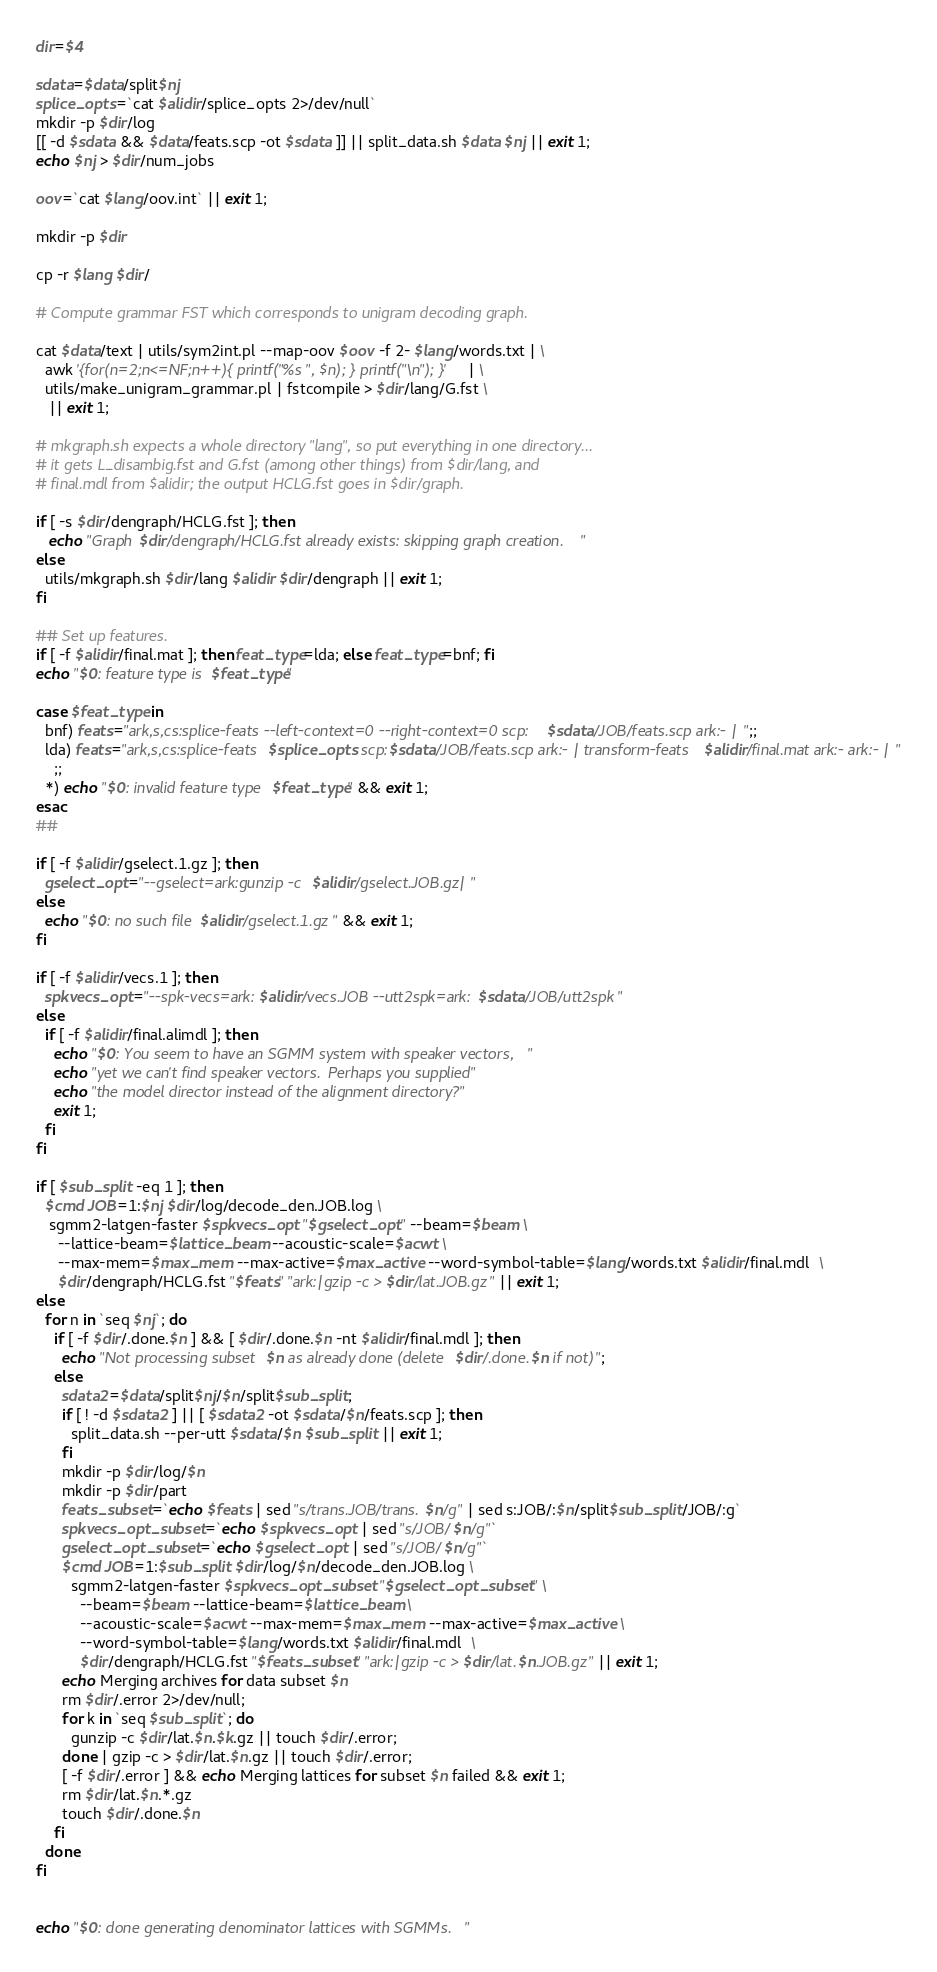<code> <loc_0><loc_0><loc_500><loc_500><_Bash_>dir=$4

sdata=$data/split$nj
splice_opts=`cat $alidir/splice_opts 2>/dev/null`
mkdir -p $dir/log
[[ -d $sdata && $data/feats.scp -ot $sdata ]] || split_data.sh $data $nj || exit 1;
echo $nj > $dir/num_jobs

oov=`cat $lang/oov.int` || exit 1;

mkdir -p $dir

cp -r $lang $dir/

# Compute grammar FST which corresponds to unigram decoding graph.

cat $data/text | utils/sym2int.pl --map-oov $oov -f 2- $lang/words.txt | \
  awk '{for(n=2;n<=NF;n++){ printf("%s ", $n); } printf("\n"); }' | \
  utils/make_unigram_grammar.pl | fstcompile > $dir/lang/G.fst \
   || exit 1;

# mkgraph.sh expects a whole directory "lang", so put everything in one directory...
# it gets L_disambig.fst and G.fst (among other things) from $dir/lang, and
# final.mdl from $alidir; the output HCLG.fst goes in $dir/graph.

if [ -s $dir/dengraph/HCLG.fst ]; then
   echo "Graph $dir/dengraph/HCLG.fst already exists: skipping graph creation."
else
  utils/mkgraph.sh $dir/lang $alidir $dir/dengraph || exit 1;
fi

## Set up features.
if [ -f $alidir/final.mat ]; then feat_type=lda; else feat_type=bnf; fi
echo "$0: feature type is $feat_type"

case $feat_type in
  bnf) feats="ark,s,cs:splice-feats --left-context=0 --right-context=0 scp:$sdata/JOB/feats.scp ark:- |";;
  lda) feats="ark,s,cs:splice-feats $splice_opts scp:$sdata/JOB/feats.scp ark:- | transform-feats $alidir/final.mat ark:- ark:- |"
    ;;
  *) echo "$0: invalid feature type $feat_type" && exit 1;
esac
##

if [ -f $alidir/gselect.1.gz ]; then
  gselect_opt="--gselect=ark:gunzip -c $alidir/gselect.JOB.gz|"
else
  echo "$0: no such file $alidir/gselect.1.gz" && exit 1;
fi

if [ -f $alidir/vecs.1 ]; then
  spkvecs_opt="--spk-vecs=ark:$alidir/vecs.JOB --utt2spk=ark:$sdata/JOB/utt2spk"
else
  if [ -f $alidir/final.alimdl ]; then
    echo "$0: You seem to have an SGMM system with speaker vectors,"
    echo "yet we can't find speaker vectors.  Perhaps you supplied"
    echo "the model director instead of the alignment directory?"
    exit 1;
  fi
fi

if [ $sub_split -eq 1 ]; then 
  $cmd JOB=1:$nj $dir/log/decode_den.JOB.log \
   sgmm2-latgen-faster $spkvecs_opt "$gselect_opt" --beam=$beam \
     --lattice-beam=$lattice_beam --acoustic-scale=$acwt \
     --max-mem=$max_mem --max-active=$max_active --word-symbol-table=$lang/words.txt $alidir/final.mdl  \
     $dir/dengraph/HCLG.fst "$feats" "ark:|gzip -c >$dir/lat.JOB.gz" || exit 1;
else
  for n in `seq $nj`; do
    if [ -f $dir/.done.$n ] && [ $dir/.done.$n -nt $alidir/final.mdl ]; then
      echo "Not processing subset $n as already done (delete $dir/.done.$n if not)";
    else 
      sdata2=$data/split$nj/$n/split$sub_split;
      if [ ! -d $sdata2 ] || [ $sdata2 -ot $sdata/$n/feats.scp ]; then
        split_data.sh --per-utt $sdata/$n $sub_split || exit 1;
      fi
      mkdir -p $dir/log/$n
      mkdir -p $dir/part
      feats_subset=`echo $feats | sed "s/trans.JOB/trans.$n/g" | sed s:JOB/:$n/split$sub_split/JOB/:g`
      spkvecs_opt_subset=`echo $spkvecs_opt | sed "s/JOB/$n/g"`
      gselect_opt_subset=`echo $gselect_opt | sed "s/JOB/$n/g"`
      $cmd JOB=1:$sub_split $dir/log/$n/decode_den.JOB.log \
        sgmm2-latgen-faster $spkvecs_opt_subset "$gselect_opt_subset" \
          --beam=$beam --lattice-beam=$lattice_beam \
          --acoustic-scale=$acwt --max-mem=$max_mem --max-active=$max_active \
          --word-symbol-table=$lang/words.txt $alidir/final.mdl  \
          $dir/dengraph/HCLG.fst "$feats_subset" "ark:|gzip -c >$dir/lat.$n.JOB.gz" || exit 1;
      echo Merging archives for data subset $n
      rm $dir/.error 2>/dev/null;
      for k in `seq $sub_split`; do
        gunzip -c $dir/lat.$n.$k.gz || touch $dir/.error;
      done | gzip -c > $dir/lat.$n.gz || touch $dir/.error;
      [ -f $dir/.error ] && echo Merging lattices for subset $n failed && exit 1;
      rm $dir/lat.$n.*.gz
      touch $dir/.done.$n
    fi
  done
fi


echo "$0: done generating denominator lattices with SGMMs."
</code> 